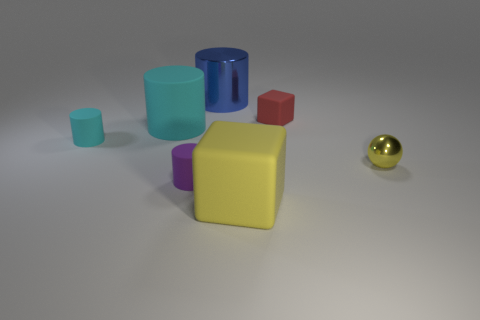Subtract 1 cylinders. How many cylinders are left? 3 Add 3 large rubber spheres. How many objects exist? 10 Subtract all cylinders. How many objects are left? 3 Subtract all small red metallic things. Subtract all large blue things. How many objects are left? 6 Add 5 large blue things. How many large blue things are left? 6 Add 2 tiny brown matte cubes. How many tiny brown matte cubes exist? 2 Subtract 0 red cylinders. How many objects are left? 7 